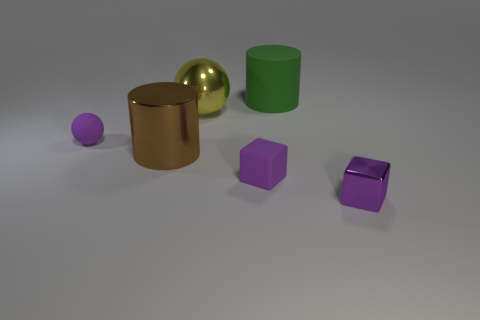Does the big brown object have the same shape as the small object to the right of the large matte thing?
Offer a very short reply. No. What number of shiny objects are large brown objects or purple balls?
Your response must be concise. 1. There is a tiny block that is left of the metal thing right of the tiny block that is on the left side of the small purple shiny object; what is its color?
Your answer should be compact. Purple. What number of other things are made of the same material as the large sphere?
Offer a very short reply. 2. There is a brown object that is left of the large yellow ball; does it have the same shape as the yellow thing?
Provide a succinct answer. No. How many large things are either green objects or yellow objects?
Ensure brevity in your answer.  2. Are there the same number of objects in front of the matte block and matte cylinders in front of the yellow object?
Offer a very short reply. No. How many other things are the same color as the metal cube?
Provide a short and direct response. 2. Does the matte cylinder have the same color as the small block that is behind the tiny purple metal object?
Your response must be concise. No. How many yellow objects are big balls or cubes?
Your answer should be very brief. 1. 